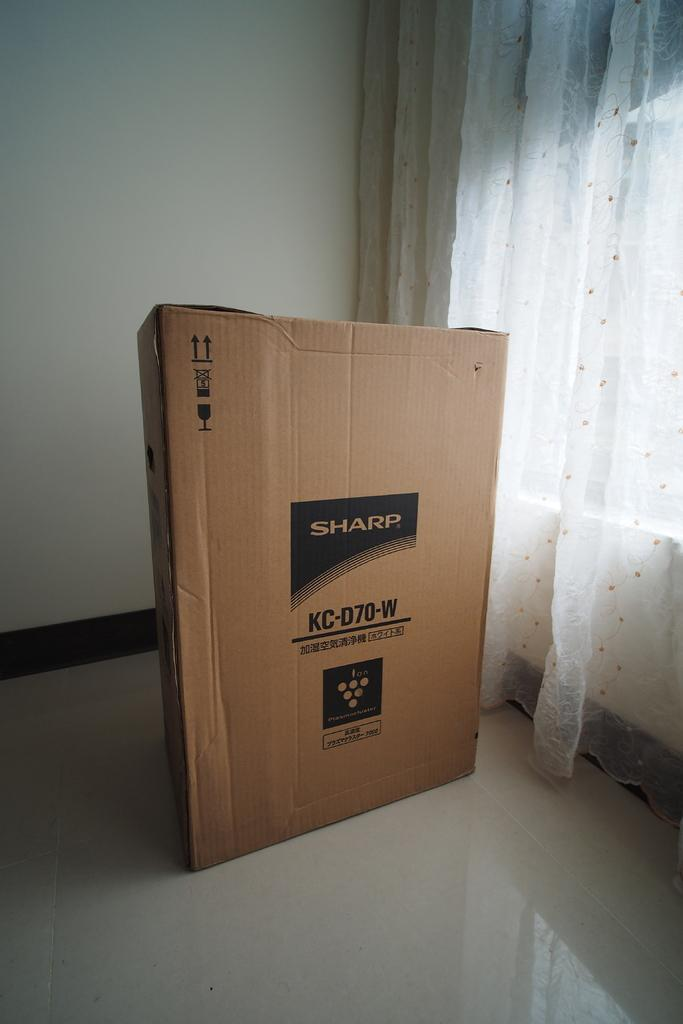<image>
Offer a succinct explanation of the picture presented. A sharp TV box is in an empty room with white curtains. 